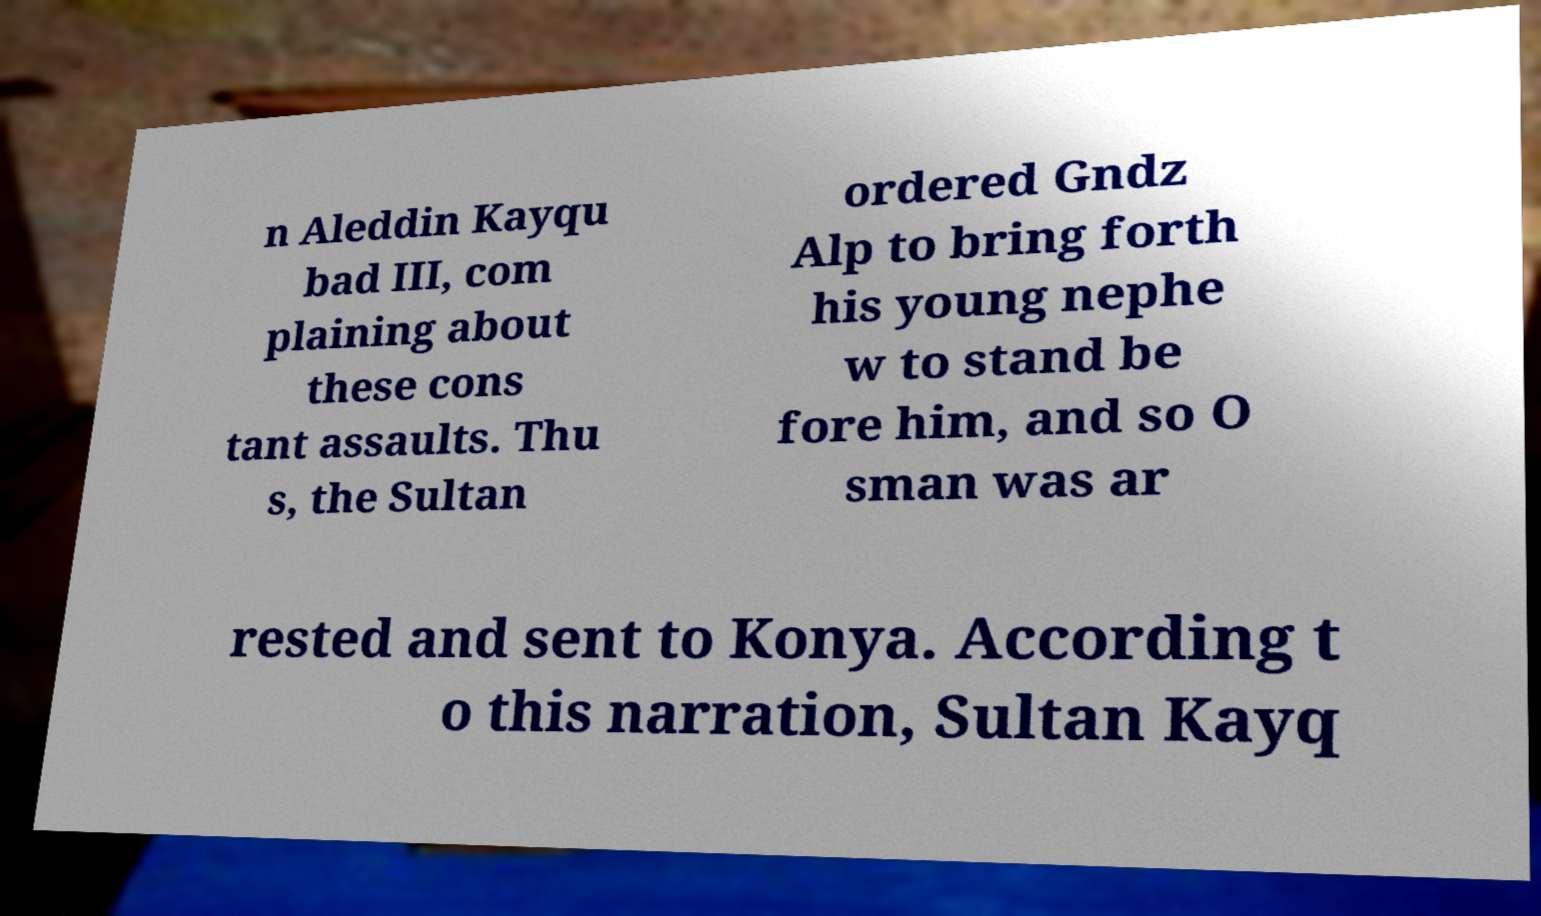Can you read and provide the text displayed in the image?This photo seems to have some interesting text. Can you extract and type it out for me? n Aleddin Kayqu bad III, com plaining about these cons tant assaults. Thu s, the Sultan ordered Gndz Alp to bring forth his young nephe w to stand be fore him, and so O sman was ar rested and sent to Konya. According t o this narration, Sultan Kayq 